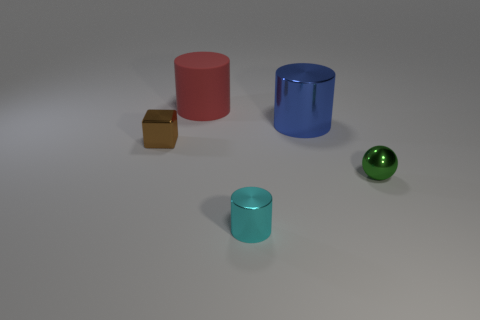Are there any other things that have the same material as the red cylinder?
Offer a terse response. No. What number of brown objects are large rubber things or large things?
Give a very brief answer. 0. How many big cyan shiny spheres are there?
Your response must be concise. 0. How big is the shiny object in front of the green thing?
Keep it short and to the point. Small. Do the cube and the blue cylinder have the same size?
Offer a very short reply. No. How many things are large red cylinders or things that are to the right of the blue cylinder?
Provide a short and direct response. 2. What is the brown object made of?
Provide a succinct answer. Metal. Is there anything else that has the same color as the large metallic object?
Offer a terse response. No. Is the brown thing the same shape as the tiny green shiny object?
Your answer should be very brief. No. How big is the cylinder in front of the tiny object that is behind the small metal thing that is on the right side of the small cylinder?
Keep it short and to the point. Small. 